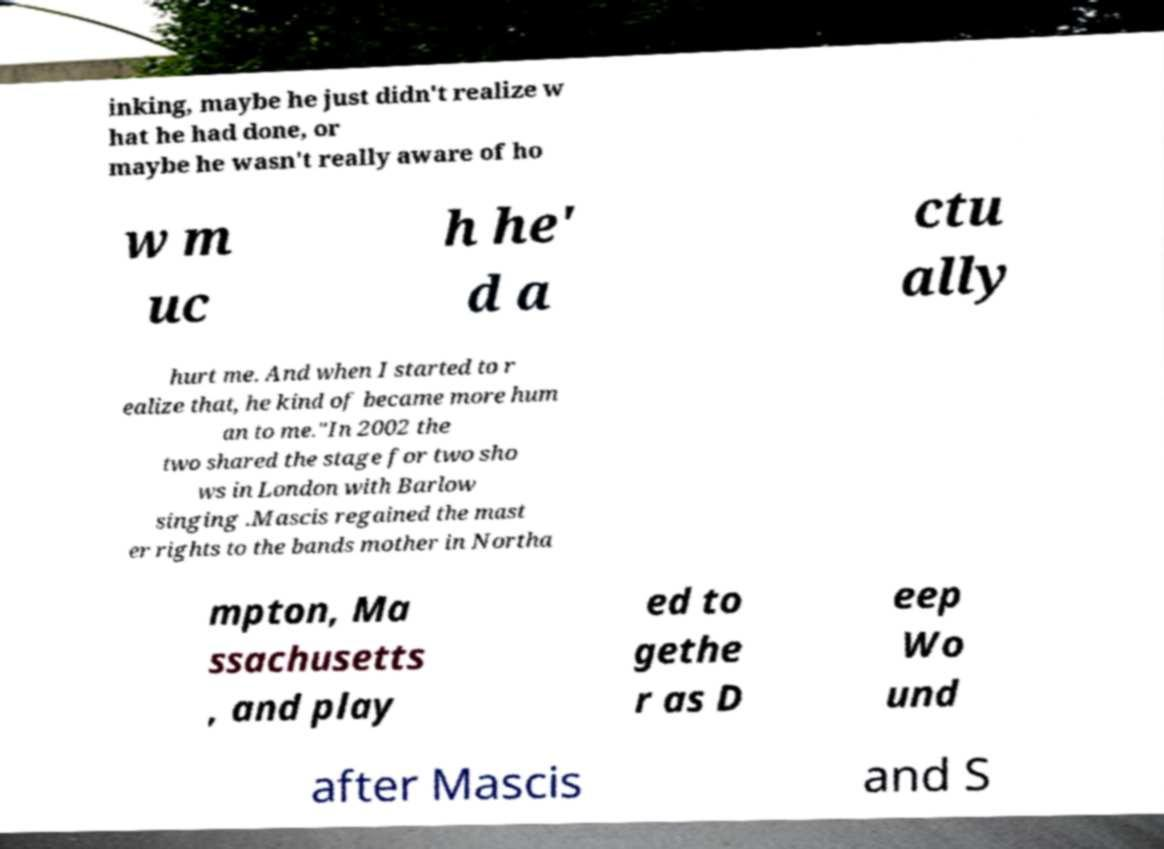What messages or text are displayed in this image? I need them in a readable, typed format. inking, maybe he just didn't realize w hat he had done, or maybe he wasn't really aware of ho w m uc h he' d a ctu ally hurt me. And when I started to r ealize that, he kind of became more hum an to me."In 2002 the two shared the stage for two sho ws in London with Barlow singing .Mascis regained the mast er rights to the bands mother in Northa mpton, Ma ssachusetts , and play ed to gethe r as D eep Wo und after Mascis and S 